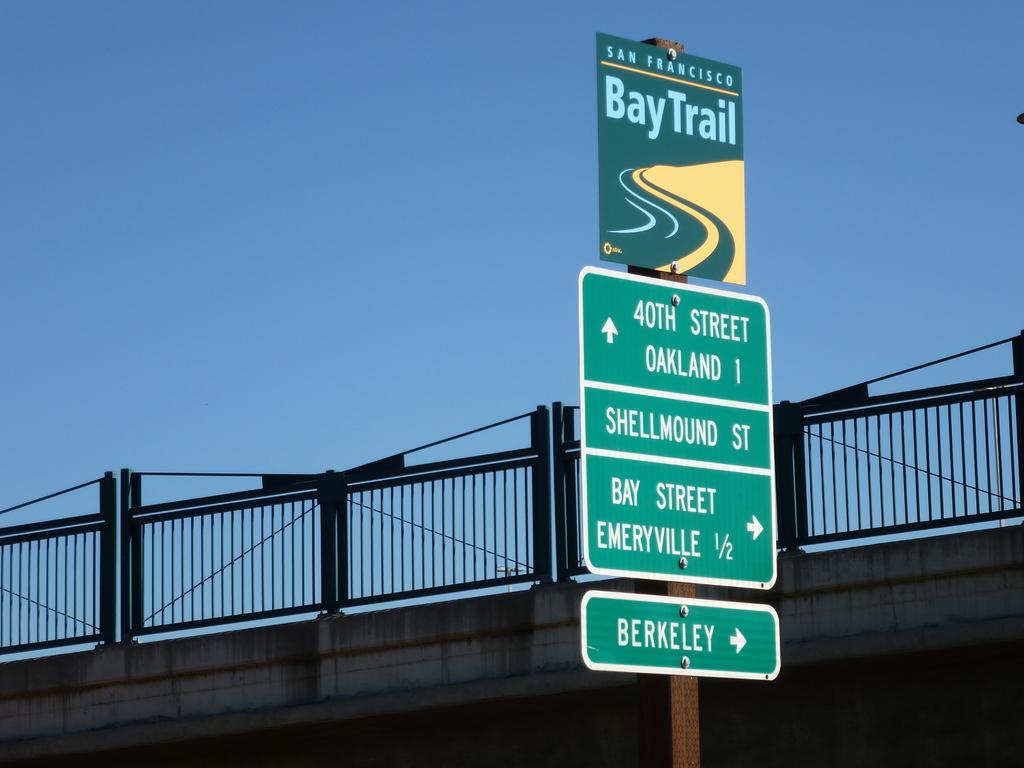Where is the baytrail located?
Keep it short and to the point. San francisco. What city is on the bottom sign?
Provide a short and direct response. Berkeley. 